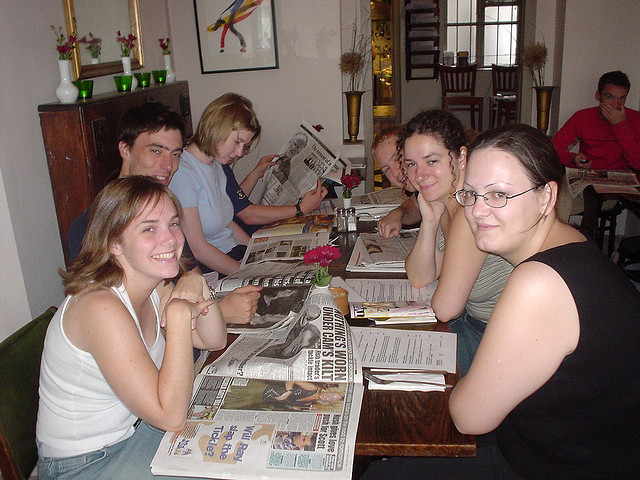What kind of place are these people in? The individuals in the image appear to be in a casually furnished room with a home-like ambiance, suggesting a small cafe or bistro. 